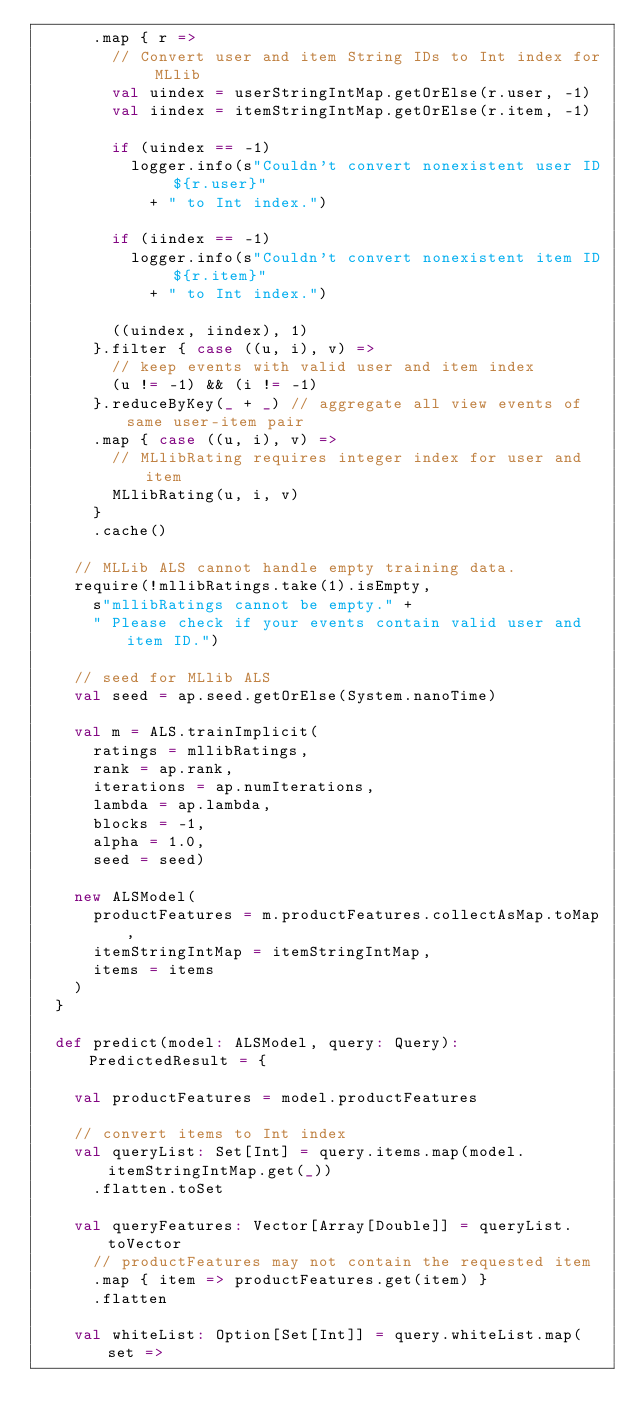Convert code to text. <code><loc_0><loc_0><loc_500><loc_500><_Scala_>      .map { r =>
        // Convert user and item String IDs to Int index for MLlib
        val uindex = userStringIntMap.getOrElse(r.user, -1)
        val iindex = itemStringIntMap.getOrElse(r.item, -1)

        if (uindex == -1)
          logger.info(s"Couldn't convert nonexistent user ID ${r.user}"
            + " to Int index.")

        if (iindex == -1)
          logger.info(s"Couldn't convert nonexistent item ID ${r.item}"
            + " to Int index.")

        ((uindex, iindex), 1)
      }.filter { case ((u, i), v) =>
        // keep events with valid user and item index
        (u != -1) && (i != -1)
      }.reduceByKey(_ + _) // aggregate all view events of same user-item pair
      .map { case ((u, i), v) =>
        // MLlibRating requires integer index for user and item
        MLlibRating(u, i, v)
      }
      .cache()

    // MLLib ALS cannot handle empty training data.
    require(!mllibRatings.take(1).isEmpty,
      s"mllibRatings cannot be empty." +
      " Please check if your events contain valid user and item ID.")

    // seed for MLlib ALS
    val seed = ap.seed.getOrElse(System.nanoTime)

    val m = ALS.trainImplicit(
      ratings = mllibRatings,
      rank = ap.rank,
      iterations = ap.numIterations,
      lambda = ap.lambda,
      blocks = -1,
      alpha = 1.0,
      seed = seed)

    new ALSModel(
      productFeatures = m.productFeatures.collectAsMap.toMap,
      itemStringIntMap = itemStringIntMap,
      items = items
    )
  }

  def predict(model: ALSModel, query: Query): PredictedResult = {

    val productFeatures = model.productFeatures

    // convert items to Int index
    val queryList: Set[Int] = query.items.map(model.itemStringIntMap.get(_))
      .flatten.toSet

    val queryFeatures: Vector[Array[Double]] = queryList.toVector
      // productFeatures may not contain the requested item
      .map { item => productFeatures.get(item) }
      .flatten

    val whiteList: Option[Set[Int]] = query.whiteList.map( set =></code> 